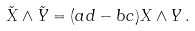Convert formula to latex. <formula><loc_0><loc_0><loc_500><loc_500>\tilde { X } \wedge \tilde { Y } = ( a d - b c ) X \wedge Y \, .</formula> 